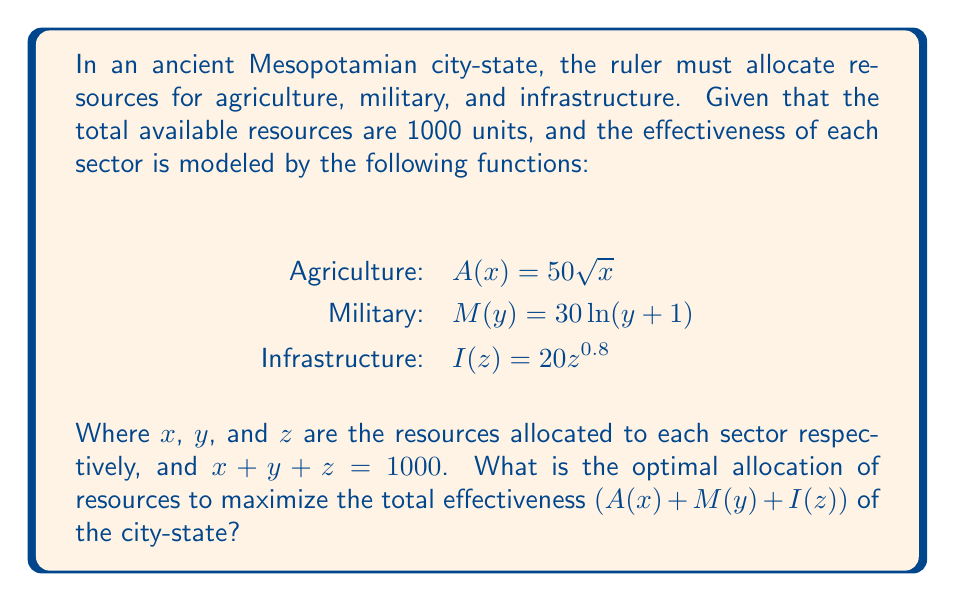What is the answer to this math problem? To solve this optimization problem, we'll use the method of Lagrange multipliers:

1. Define the objective function:
   $f(x,y,z) = 50\sqrt{x} + 30\ln(y+1) + 20z^{0.8}$

2. Define the constraint:
   $g(x,y,z) = x + y + z - 1000 = 0$

3. Form the Lagrangian:
   $L(x,y,z,\lambda) = f(x,y,z) - \lambda g(x,y,z)$
   $L(x,y,z,\lambda) = 50\sqrt{x} + 30\ln(y+1) + 20z^{0.8} - \lambda(x + y + z - 1000)$

4. Take partial derivatives and set them to zero:
   $\frac{\partial L}{\partial x} = \frac{25}{\sqrt{x}} - \lambda = 0$
   $\frac{\partial L}{\partial y} = \frac{30}{y+1} - \lambda = 0$
   $\frac{\partial L}{\partial z} = 16z^{-0.2} - \lambda = 0$
   $\frac{\partial L}{\partial \lambda} = x + y + z - 1000 = 0$

5. From these equations, we can derive:
   $x = (\frac{25}{\lambda})^2$
   $y = \frac{30}{\lambda} - 1$
   $z = (\frac{16}{\lambda})^{5}$

6. Substitute these into the constraint equation:
   $(\frac{25}{\lambda})^2 + \frac{30}{\lambda} - 1 + (\frac{16}{\lambda})^{5} = 1000$

7. Solve this equation numerically (using a computer or calculator) to find $\lambda \approx 0.1583$

8. Substitute this value back into the expressions for $x$, $y$, and $z$:
   $x \approx 24964$
   $y \approx 188$
   $z \approx 74848$

9. Since these values sum to more than 1000, we need to scale them down proportionally:
   Total = 24964 + 188 + 74848 = 100000
   
   $x = 1000 * \frac{24964}{100000} \approx 250$
   $y = 1000 * \frac{188}{100000} \approx 2$
   $z = 1000 * \frac{74848}{100000} \approx 748$

Therefore, the optimal allocation is approximately 250 units to agriculture, 2 units to military, and 748 units to infrastructure.
Answer: Agriculture: 250, Military: 2, Infrastructure: 748 